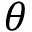Convert formula to latex. <formula><loc_0><loc_0><loc_500><loc_500>\theta</formula> 